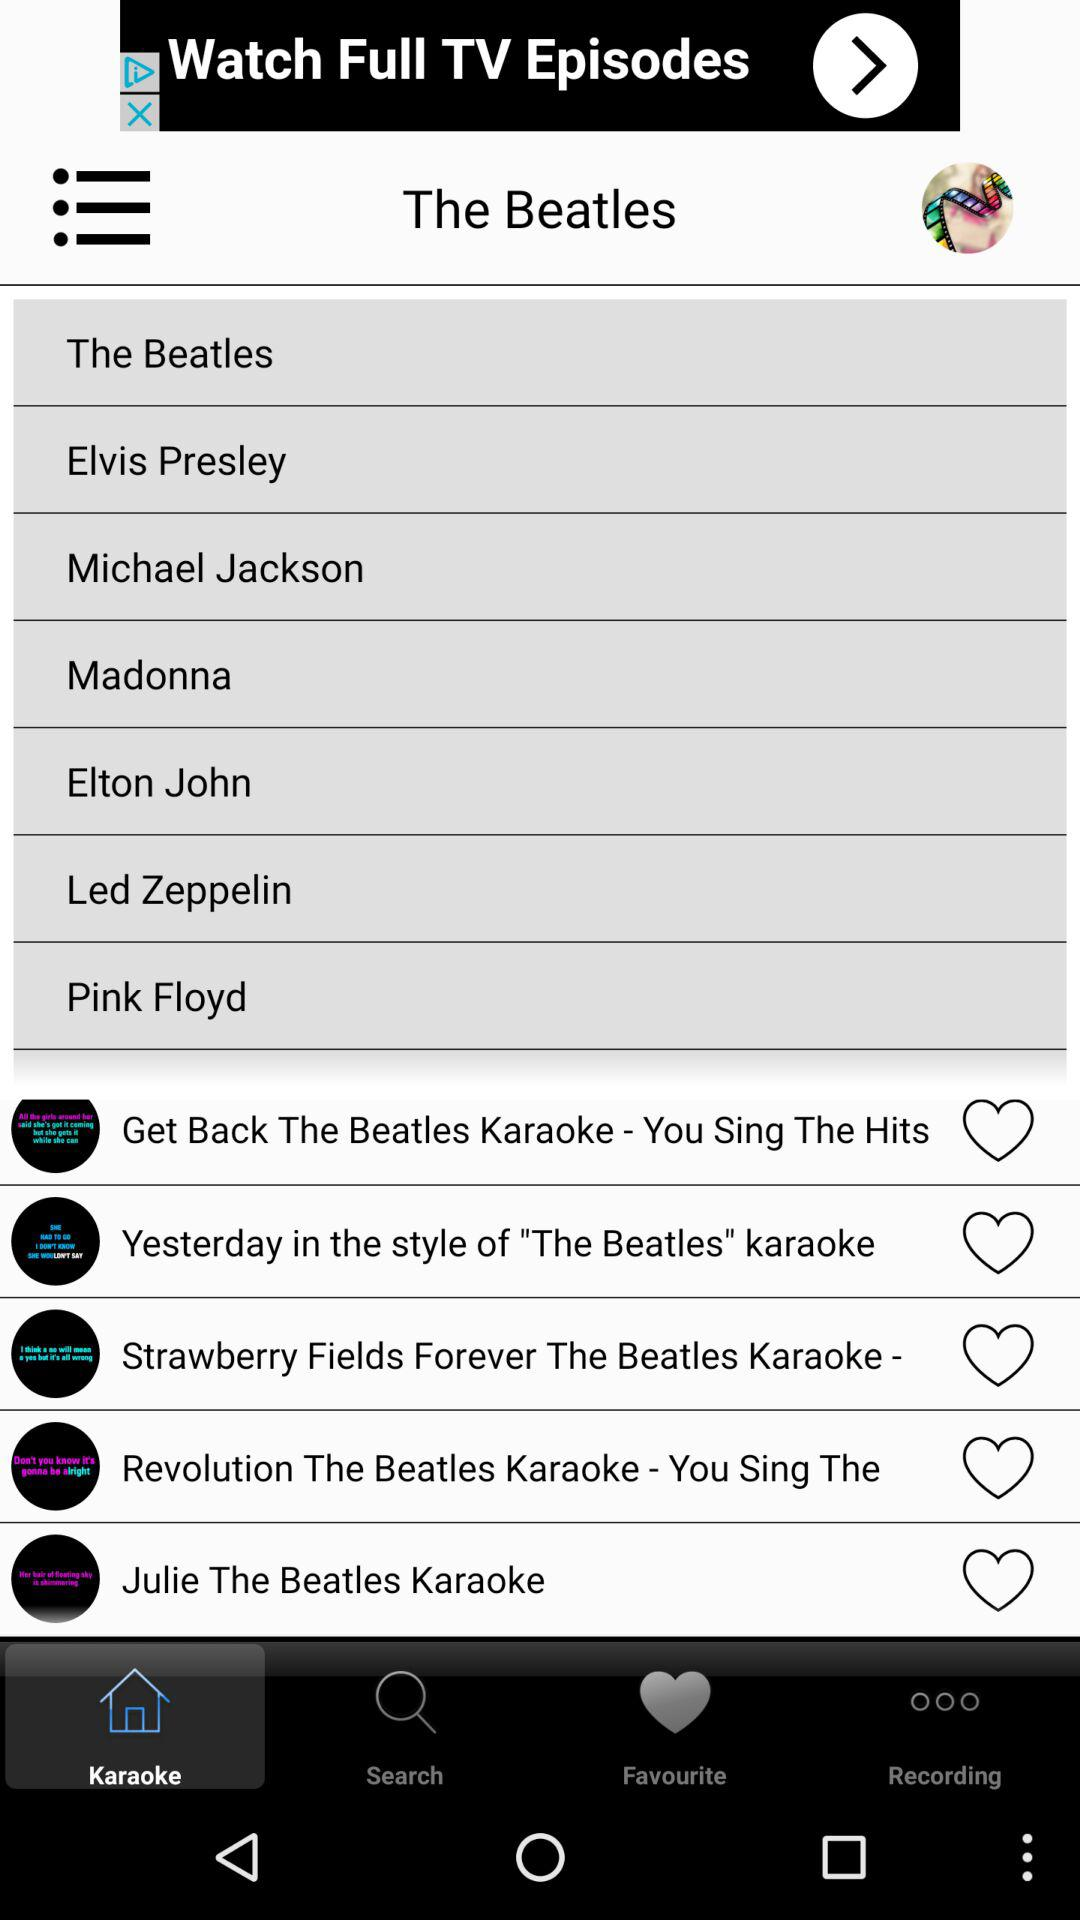Which tab is selected? The selected tab is "Karaoke". 